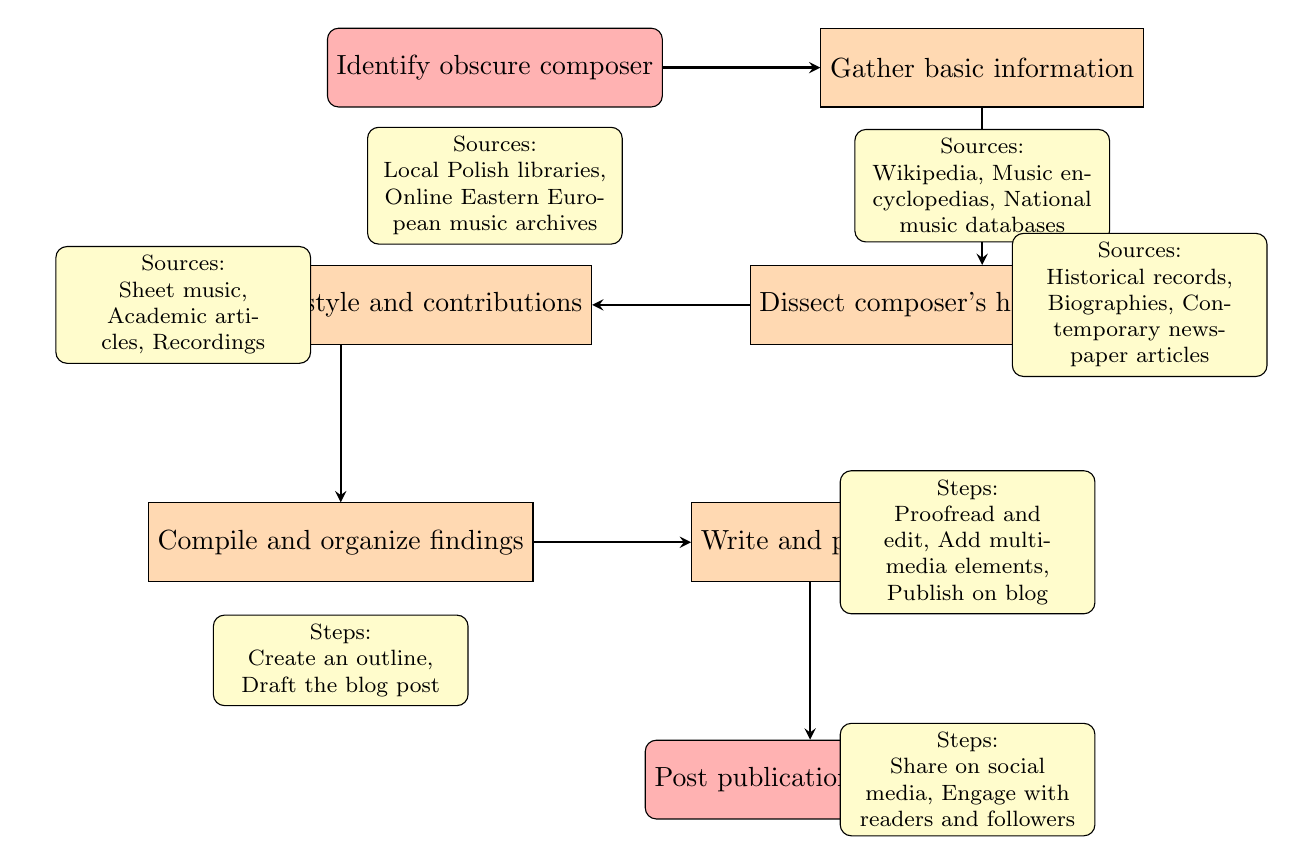What is the first step in the workflow? The first step in the workflow is to "Identify obscure composer." This can be found at the start of the flowchart, indicating it is the initial task to undertake.
Answer: Identify obscure composer How many nodes are there in the diagram? The diagram contains a total of 7 nodes, including the starting point and endpoint. These nodes represent different stages in the workflow process, leading from identification to outreach.
Answer: 7 What follows after "Gather basic information"? After "Gather basic information," the next step is "Dissect composer's historical context." This flow indicates the progression from gathering initial info to understanding the context surrounding the composer.
Answer: Dissect composer's historical context Which sources are listed for analyzing musical style and contributions? The sources listed for this stage are "Sheet music, Academic articles, Recordings." These sources are essential for conducting a thorough analysis of the composer's style and contributions.
Answer: Sheet music, Academic articles, Recordings What are the steps involved in the "Write and publish" phase? The steps are "Proofread and edit, Add multimedia elements, Publish on blog." These steps detail the necessary actions to complete the writing and publishing process before outreach.
Answer: Proofread and edit, Add multimedia elements, Publish on blog Which step comes directly after "Compile and organize findings"? The step that follows "Compile and organize findings" is "Write and publish." This indicates that once the findings are organized, the writing process begins.
Answer: Write and publish What is the last phase in the diagram? The last phase in the diagram is "Post publication outreach." This is the final step where actions are taken to promote the published work and engage the audience.
Answer: Post publication outreach What node includes sources from historical records? The node "Dissect composer's historical context" includes sources from historical records. This indicates that understanding the historical background is crucial for this stage of research.
Answer: Dissect composer's historical context What is required in the phase before "Write and publish"? The phase before "Write and publish" requires "Compile and organize findings." This means that the findings need to be logically ordered and structured before writing can occur.
Answer: Compile and organize findings 